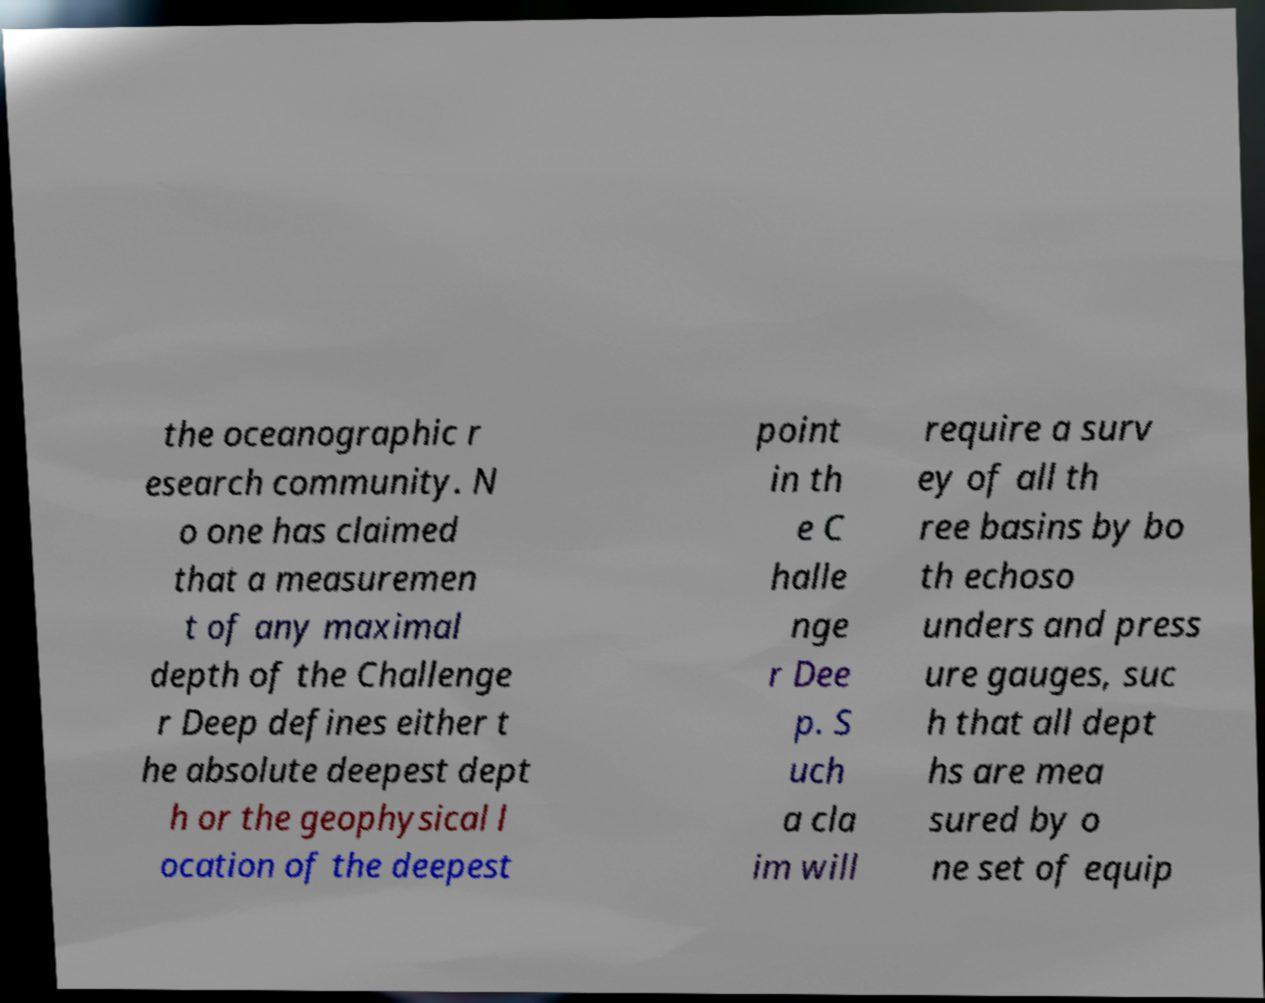Please read and relay the text visible in this image. What does it say? the oceanographic r esearch community. N o one has claimed that a measuremen t of any maximal depth of the Challenge r Deep defines either t he absolute deepest dept h or the geophysical l ocation of the deepest point in th e C halle nge r Dee p. S uch a cla im will require a surv ey of all th ree basins by bo th echoso unders and press ure gauges, suc h that all dept hs are mea sured by o ne set of equip 